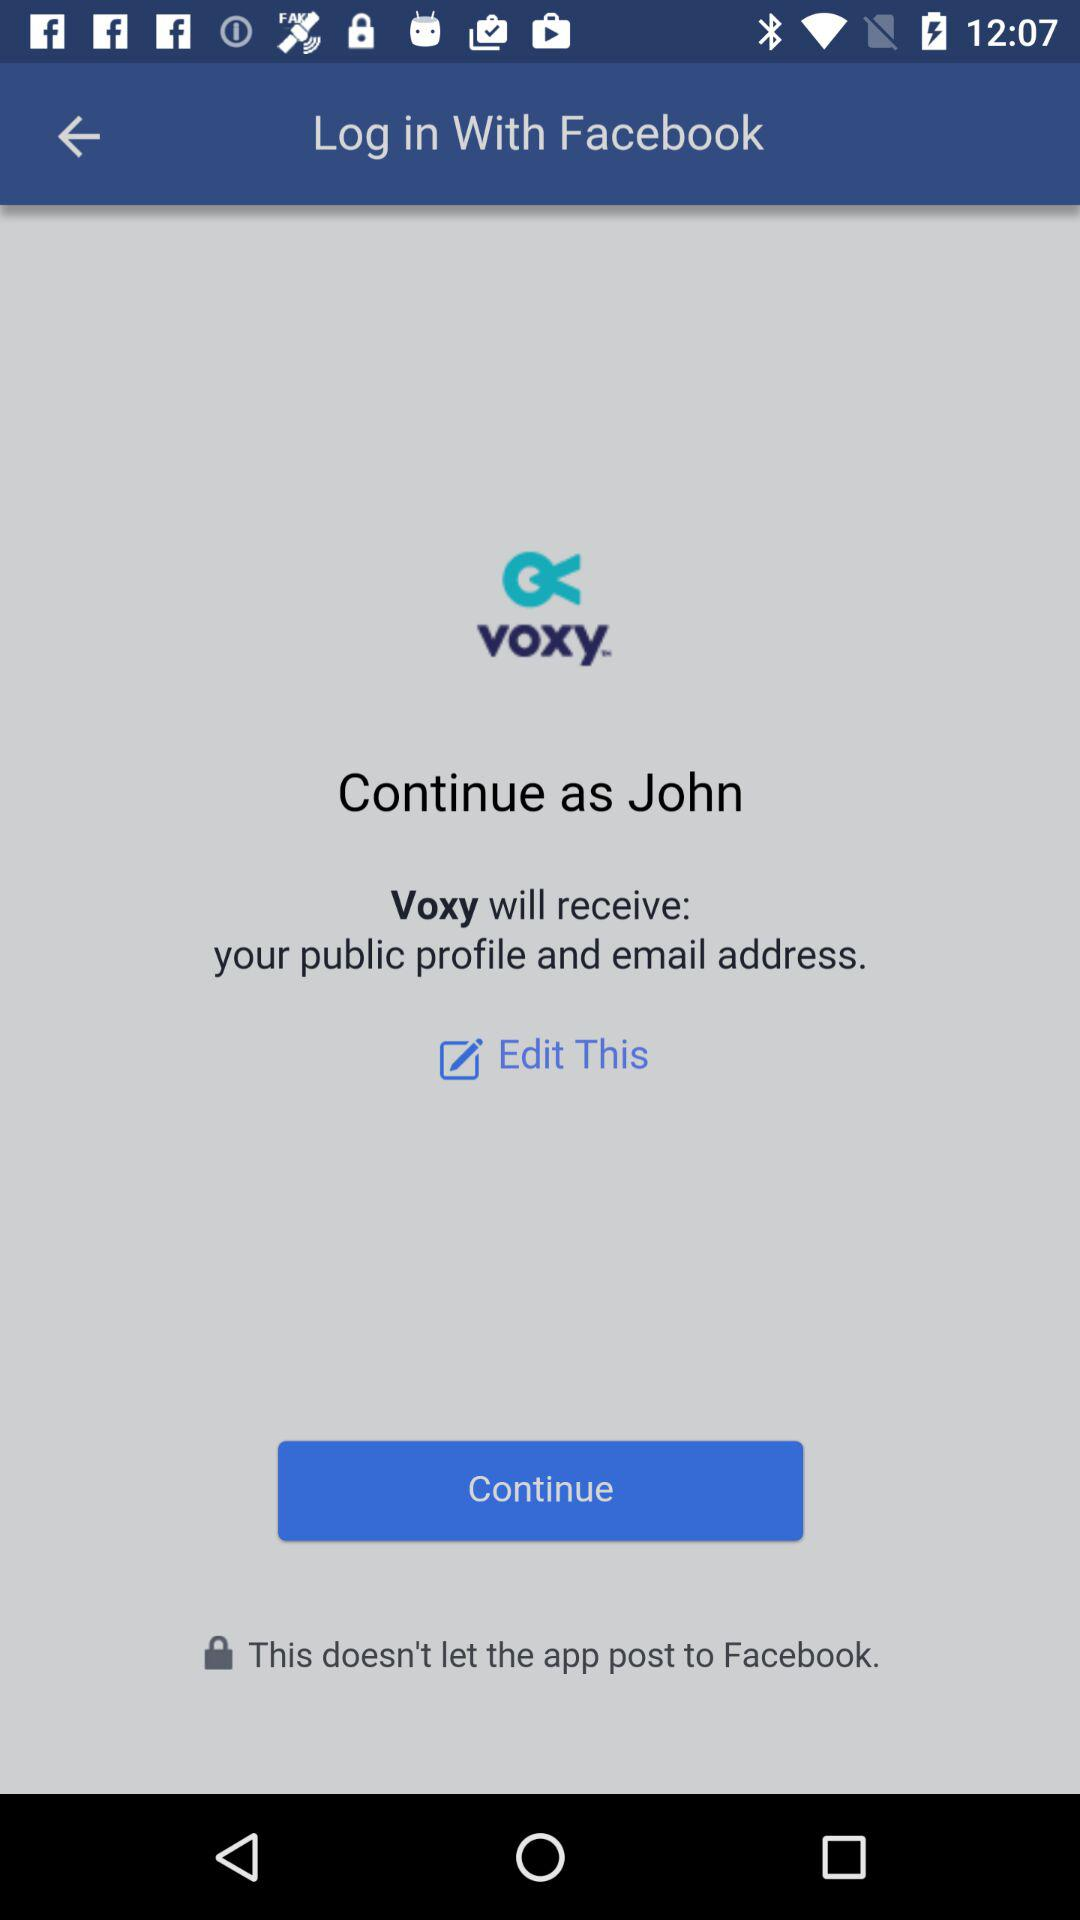What application is asking for permission? The application asking for permission is "Voxy". 